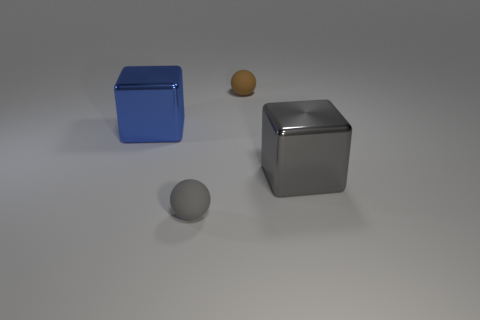How many blocks are yellow things or large metal things?
Offer a terse response. 2. What size is the rubber thing in front of the matte object that is right of the rubber thing in front of the small brown rubber thing?
Keep it short and to the point. Small. There is a gray object that is the same size as the brown rubber object; what is its shape?
Provide a succinct answer. Sphere. What is the shape of the brown matte object?
Give a very brief answer. Sphere. Are the big cube right of the tiny brown rubber thing and the small brown sphere made of the same material?
Your answer should be very brief. No. There is a metal thing that is on the left side of the ball to the left of the brown object; how big is it?
Provide a succinct answer. Large. What color is the thing that is left of the large gray metallic object and on the right side of the gray matte sphere?
Provide a short and direct response. Brown. There is a gray block that is the same size as the blue object; what is it made of?
Your answer should be compact. Metal. How many other things are made of the same material as the large gray thing?
Your answer should be very brief. 1. Does the big object on the left side of the brown rubber thing have the same color as the shiny block right of the brown rubber ball?
Provide a succinct answer. No. 